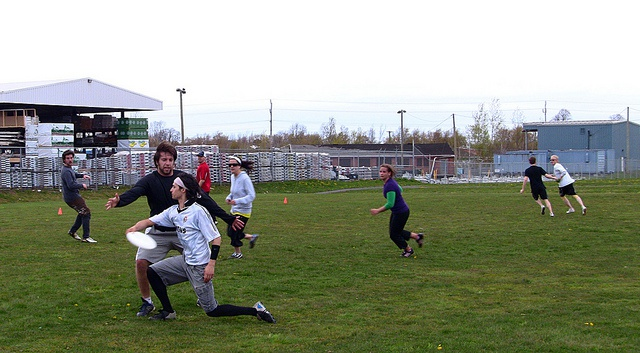Describe the objects in this image and their specific colors. I can see people in white, black, gray, darkgray, and lavender tones, people in white, black, gray, maroon, and brown tones, people in white, black, darkgreen, navy, and gray tones, people in white, black, gray, navy, and darkgreen tones, and people in white, darkgray, black, gray, and lavender tones in this image. 